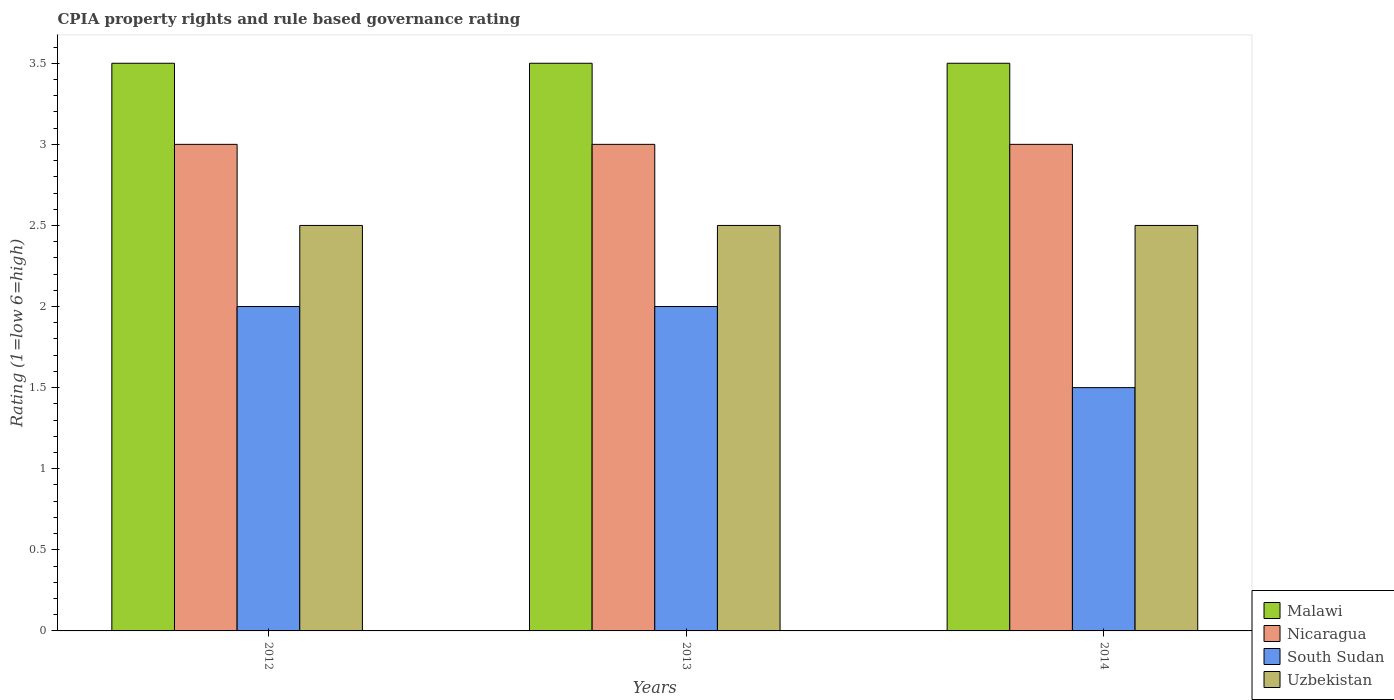How many groups of bars are there?
Provide a short and direct response. 3. Are the number of bars on each tick of the X-axis equal?
Offer a very short reply. Yes. What is the label of the 3rd group of bars from the left?
Your answer should be very brief. 2014. Across all years, what is the maximum CPIA rating in South Sudan?
Your response must be concise. 2. Across all years, what is the minimum CPIA rating in Nicaragua?
Your answer should be very brief. 3. In which year was the CPIA rating in South Sudan maximum?
Offer a terse response. 2012. What is the difference between the CPIA rating in Malawi in 2012 and the CPIA rating in Nicaragua in 2013?
Offer a very short reply. 0.5. In the year 2013, what is the difference between the CPIA rating in Nicaragua and CPIA rating in Malawi?
Offer a very short reply. -0.5. Is the CPIA rating in Uzbekistan in 2013 less than that in 2014?
Your answer should be compact. No. Is the difference between the CPIA rating in Nicaragua in 2013 and 2014 greater than the difference between the CPIA rating in Malawi in 2013 and 2014?
Provide a short and direct response. No. What is the difference between the highest and the lowest CPIA rating in Nicaragua?
Give a very brief answer. 0. Is it the case that in every year, the sum of the CPIA rating in Malawi and CPIA rating in Uzbekistan is greater than the sum of CPIA rating in Nicaragua and CPIA rating in South Sudan?
Make the answer very short. No. What does the 2nd bar from the left in 2013 represents?
Ensure brevity in your answer.  Nicaragua. What does the 2nd bar from the right in 2013 represents?
Your response must be concise. South Sudan. Are all the bars in the graph horizontal?
Your answer should be compact. No. How many years are there in the graph?
Your answer should be very brief. 3. Are the values on the major ticks of Y-axis written in scientific E-notation?
Provide a succinct answer. No. Does the graph contain any zero values?
Offer a very short reply. No. What is the title of the graph?
Provide a succinct answer. CPIA property rights and rule based governance rating. Does "United Arab Emirates" appear as one of the legend labels in the graph?
Give a very brief answer. No. What is the label or title of the X-axis?
Offer a terse response. Years. What is the label or title of the Y-axis?
Offer a very short reply. Rating (1=low 6=high). What is the Rating (1=low 6=high) of Malawi in 2012?
Keep it short and to the point. 3.5. What is the Rating (1=low 6=high) in Uzbekistan in 2012?
Give a very brief answer. 2.5. What is the Rating (1=low 6=high) of Uzbekistan in 2013?
Give a very brief answer. 2.5. What is the Rating (1=low 6=high) of South Sudan in 2014?
Keep it short and to the point. 1.5. Across all years, what is the maximum Rating (1=low 6=high) of Malawi?
Offer a terse response. 3.5. Across all years, what is the maximum Rating (1=low 6=high) in Uzbekistan?
Your answer should be very brief. 2.5. Across all years, what is the minimum Rating (1=low 6=high) in Malawi?
Keep it short and to the point. 3.5. Across all years, what is the minimum Rating (1=low 6=high) in Uzbekistan?
Offer a very short reply. 2.5. What is the total Rating (1=low 6=high) in Malawi in the graph?
Your response must be concise. 10.5. What is the total Rating (1=low 6=high) of South Sudan in the graph?
Your answer should be very brief. 5.5. What is the difference between the Rating (1=low 6=high) in Malawi in 2012 and that in 2013?
Make the answer very short. 0. What is the difference between the Rating (1=low 6=high) of Nicaragua in 2012 and that in 2014?
Offer a terse response. 0. What is the difference between the Rating (1=low 6=high) in Nicaragua in 2013 and that in 2014?
Make the answer very short. 0. What is the difference between the Rating (1=low 6=high) of Uzbekistan in 2013 and that in 2014?
Provide a succinct answer. 0. What is the difference between the Rating (1=low 6=high) in Malawi in 2012 and the Rating (1=low 6=high) in Nicaragua in 2013?
Your response must be concise. 0.5. What is the difference between the Rating (1=low 6=high) in Malawi in 2012 and the Rating (1=low 6=high) in South Sudan in 2013?
Offer a terse response. 1.5. What is the difference between the Rating (1=low 6=high) in Nicaragua in 2012 and the Rating (1=low 6=high) in South Sudan in 2013?
Offer a very short reply. 1. What is the difference between the Rating (1=low 6=high) of Nicaragua in 2012 and the Rating (1=low 6=high) of Uzbekistan in 2013?
Offer a very short reply. 0.5. What is the difference between the Rating (1=low 6=high) of Malawi in 2012 and the Rating (1=low 6=high) of Nicaragua in 2014?
Offer a terse response. 0.5. What is the difference between the Rating (1=low 6=high) of Malawi in 2012 and the Rating (1=low 6=high) of South Sudan in 2014?
Your answer should be compact. 2. What is the difference between the Rating (1=low 6=high) of Malawi in 2012 and the Rating (1=low 6=high) of Uzbekistan in 2014?
Offer a terse response. 1. What is the difference between the Rating (1=low 6=high) in Nicaragua in 2012 and the Rating (1=low 6=high) in South Sudan in 2014?
Give a very brief answer. 1.5. What is the difference between the Rating (1=low 6=high) in South Sudan in 2012 and the Rating (1=low 6=high) in Uzbekistan in 2014?
Your answer should be compact. -0.5. What is the difference between the Rating (1=low 6=high) in Malawi in 2013 and the Rating (1=low 6=high) in Nicaragua in 2014?
Your response must be concise. 0.5. What is the difference between the Rating (1=low 6=high) in Malawi in 2013 and the Rating (1=low 6=high) in South Sudan in 2014?
Ensure brevity in your answer.  2. What is the difference between the Rating (1=low 6=high) of Nicaragua in 2013 and the Rating (1=low 6=high) of South Sudan in 2014?
Your answer should be very brief. 1.5. What is the average Rating (1=low 6=high) of South Sudan per year?
Offer a very short reply. 1.83. What is the average Rating (1=low 6=high) of Uzbekistan per year?
Offer a terse response. 2.5. In the year 2012, what is the difference between the Rating (1=low 6=high) of Nicaragua and Rating (1=low 6=high) of Uzbekistan?
Offer a very short reply. 0.5. In the year 2013, what is the difference between the Rating (1=low 6=high) of Malawi and Rating (1=low 6=high) of Uzbekistan?
Give a very brief answer. 1. In the year 2013, what is the difference between the Rating (1=low 6=high) of Nicaragua and Rating (1=low 6=high) of South Sudan?
Your answer should be compact. 1. In the year 2013, what is the difference between the Rating (1=low 6=high) of Nicaragua and Rating (1=low 6=high) of Uzbekistan?
Give a very brief answer. 0.5. In the year 2013, what is the difference between the Rating (1=low 6=high) in South Sudan and Rating (1=low 6=high) in Uzbekistan?
Provide a succinct answer. -0.5. What is the ratio of the Rating (1=low 6=high) in South Sudan in 2012 to that in 2013?
Your response must be concise. 1. What is the ratio of the Rating (1=low 6=high) in Uzbekistan in 2012 to that in 2014?
Provide a succinct answer. 1. What is the ratio of the Rating (1=low 6=high) of Malawi in 2013 to that in 2014?
Your answer should be compact. 1. What is the ratio of the Rating (1=low 6=high) of Uzbekistan in 2013 to that in 2014?
Keep it short and to the point. 1. What is the difference between the highest and the second highest Rating (1=low 6=high) in Malawi?
Provide a short and direct response. 0. What is the difference between the highest and the second highest Rating (1=low 6=high) in South Sudan?
Your answer should be compact. 0. What is the difference between the highest and the second highest Rating (1=low 6=high) in Uzbekistan?
Provide a short and direct response. 0. What is the difference between the highest and the lowest Rating (1=low 6=high) in Malawi?
Offer a terse response. 0. 